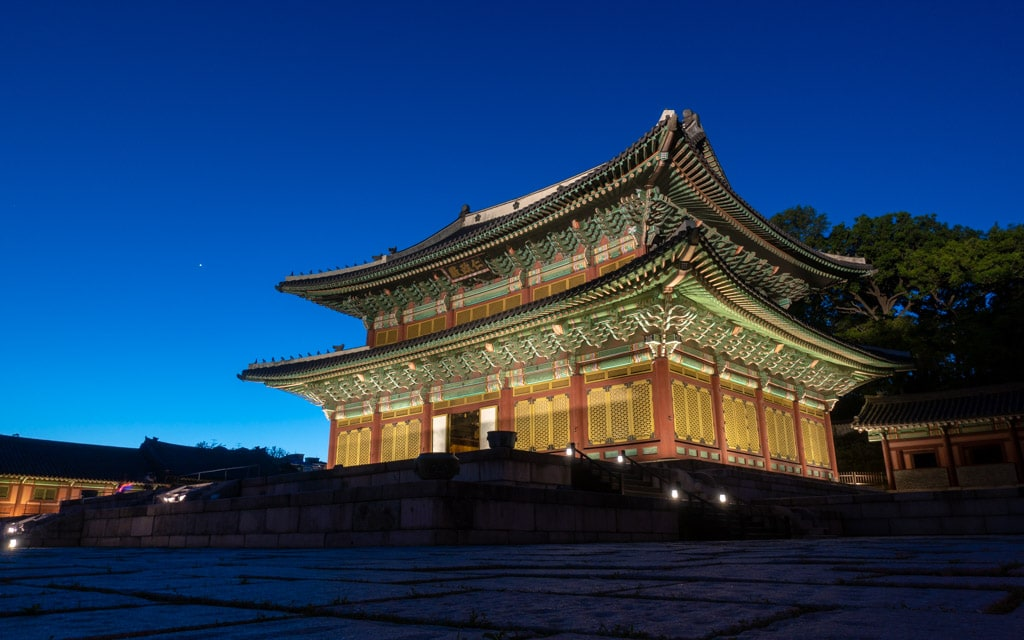Can you elaborate on the elements of the picture provided? The image showcases the stunning Changdeokgung Palace in Seoul, South Korea, captured during the night. The palace, well-lit and vibrant, stands as a quintessential example of Joseon Dynasty architecture. With its harmonious balance of the painted wooden structures and intricately designed roof tiles, the image highlights traditional Korean aesthetics. Notably, the palace is enveloped by a natural setting that adds tranquility and emphasizes the traditional Korean philosophy of incorporating nature into architecture. This scene not only captivates with its beauty but also represents a crucial piece of Korea's cultural heritage, specifically as a UNESCO World Heritage site, which has preserved centuries of history and art. 